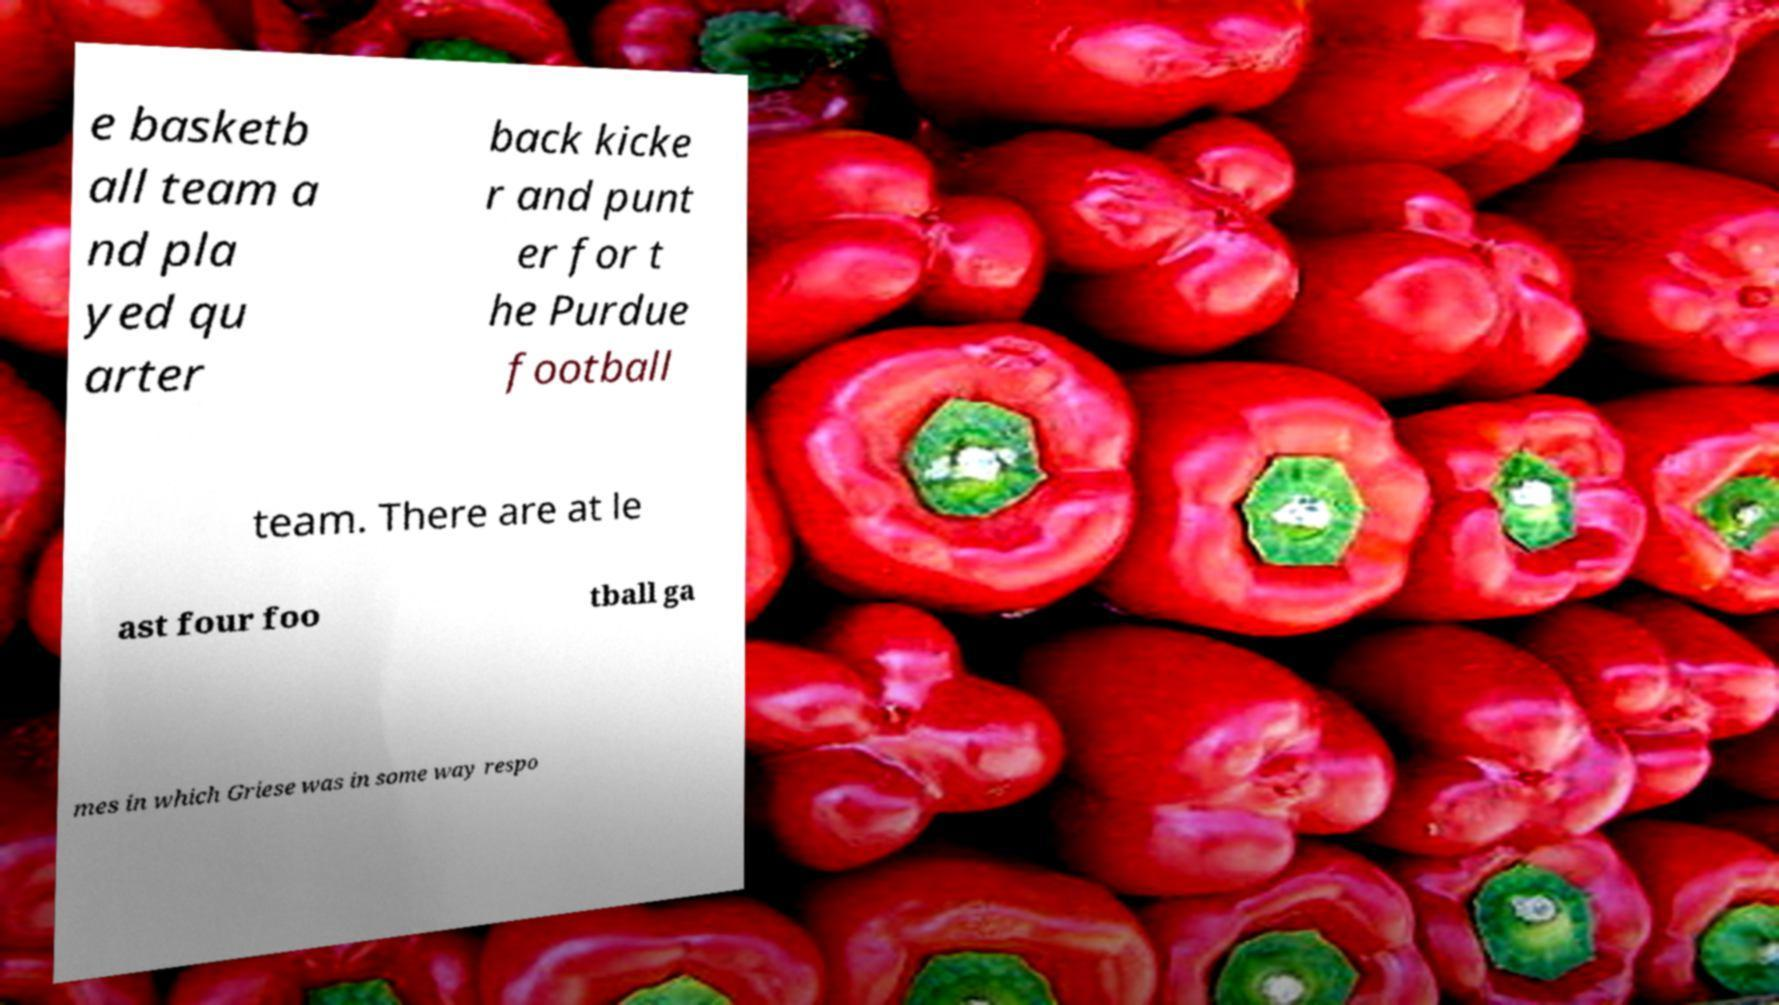I need the written content from this picture converted into text. Can you do that? e basketb all team a nd pla yed qu arter back kicke r and punt er for t he Purdue football team. There are at le ast four foo tball ga mes in which Griese was in some way respo 